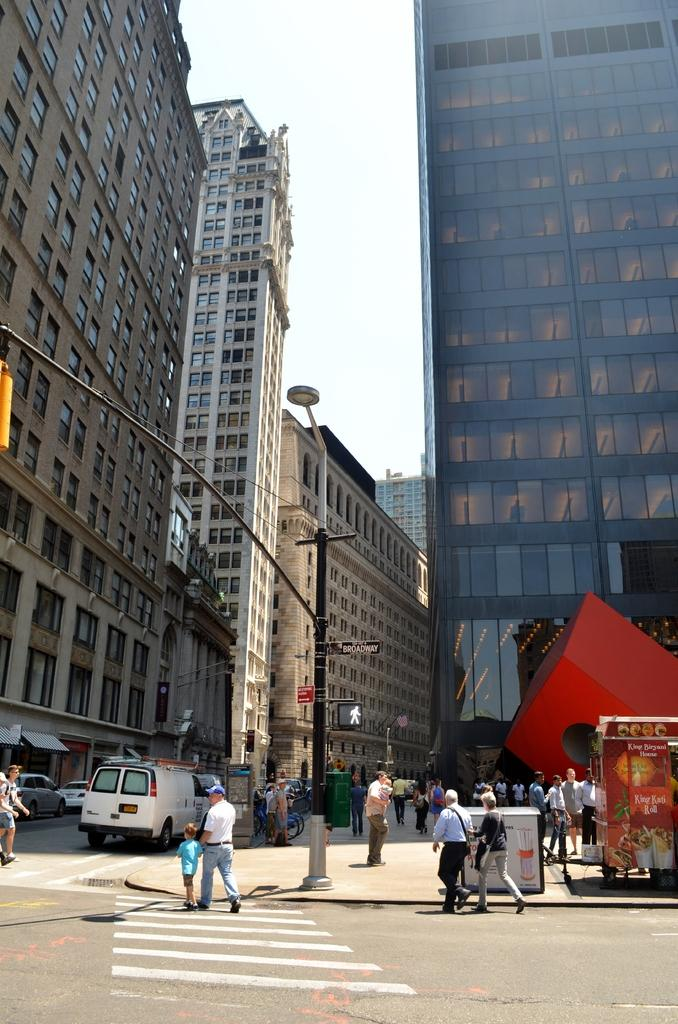Who or what can be seen in the image? There are people and vehicles in the image. What is the pole in the image used for? The pole in the image is likely used for supporting the light. What are the boards in the image used for? The boards in the image might be used for signage or advertisements. What type of surface can be seen in the image? There is a road in the image. What structures are visible in the background of the image? There are buildings in the image. What is visible in the sky in the background of the image? The sky is visible in the background of the image. What type of liquid is being poured from the beast's mouth in the image? There is no beast or liquid present in the image. What advice is being given by the person in the image? There is no person giving advice in the image. 